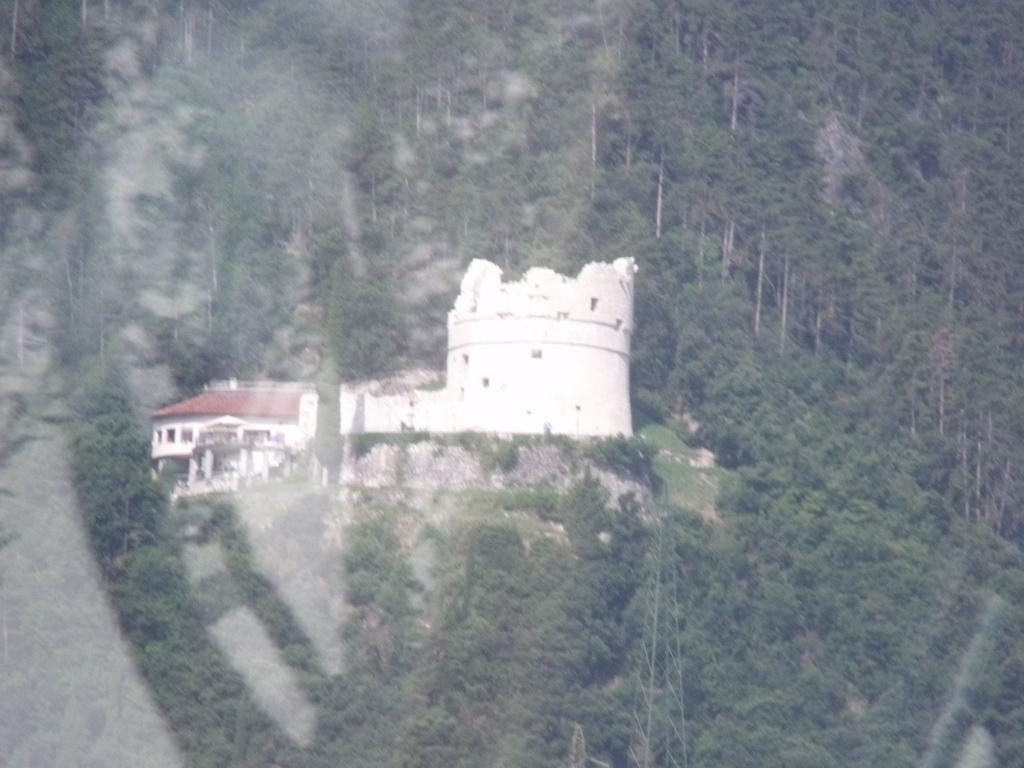What type of structures can be seen in the image? There are buildings in the image. What natural feature is present in the image? There is a hill in the image. What type of vegetation is visible in the image? There are many trees in the image. What type of grain can be seen growing on the street in the image? There is no street or grain present in the image; it features buildings, a hill, and trees. 